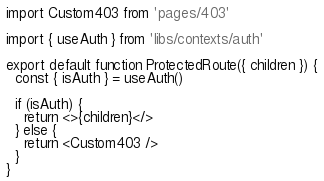<code> <loc_0><loc_0><loc_500><loc_500><_JavaScript_>import Custom403 from 'pages/403'

import { useAuth } from 'libs/contexts/auth'

export default function ProtectedRoute({ children }) {
  const { isAuth } = useAuth()

  if (isAuth) {
    return <>{children}</>
  } else {
    return <Custom403 />
  }
}
</code> 